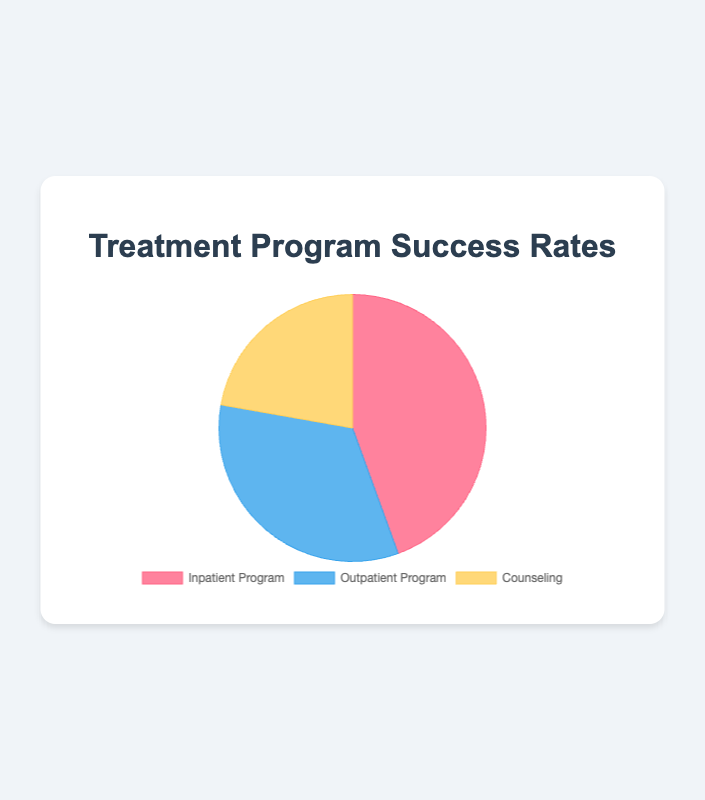what are the success rates for each treatment program? The pie chart shows the success rates for three treatment programs: Inpatient Program, Outpatient Program, and Counseling. We can read the values directly from the chart: Inpatient Program = 60%, Outpatient Program = 45%, Counseling = 30%
Answer: Inpatient: 60%, Outpatient: 45%, Counseling: 30% which treatment program has the highest success rate? By examining the success rates from the pie chart, we can see that the Inpatient Program has the highest success rate at 60%
Answer: Inpatient Program which treatment program has the lowest success rate? The pie chart indicates that Counseling has the lowest success rate with a value of 30%
Answer: Counseling how much higher is the success rate of the inpatient program compared to the outpatient program? The success rate of the Inpatient Program is 60%, and the Outpatient Program is 45%. The difference between them is 60% - 45% = 15%
Answer: 15% what is the total percentage of success rates from all three programs? To find the total percentage, we sum up the success rates of all three programs: 60% (Inpatient) + 45% (Outpatient) + 30% (Counseling) = 135%
Answer: 135% which two programs combined have a higher success rate than the third program? We need to consider all pair combinations: 
- Inpatient (60%) + Outpatient (45%) = 105% 
- Inpatient (60%) + Counseling (30%) = 90% 
- Outpatient (45%) + Counseling (30%) = 75%
The combinations of Inpatient + Outpatient and Inpatient + Counseling both have higher total success rates than any single program.
Answer: Inpatient + Outpatient, Inpatient + Counseling what is the average success rate across all three programs? The average success rate is calculated by summing the success rates of the three programs and dividing by the number of programs. (60% + 45% + 30%) / 3 = 135% / 3 = 45%
Answer: 45% which program success rate is closest to the average success rate? The average success rate is 45%. Comparing each program's rate to 45%: Inpatient (60%), Outpatient (45%), Counseling (30%). The Outpatient Program's success rate of 45% is exactly the average.
Answer: Outpatient Program how much more successful is the inpatient program compared to counseling in percentage points? The success rate of the Inpatient Program is 60%, while Counseling is 30%. The difference between them is 60% - 30% = 30%
Answer: 30% which segment of the pie chart is represented by the color red? The visual attributes of the pie chart indicate that the color red corresponds to the Inpatient Program.
Answer: Inpatient Program 